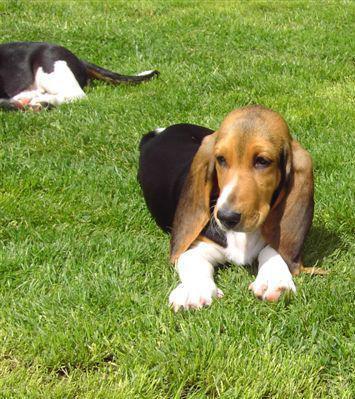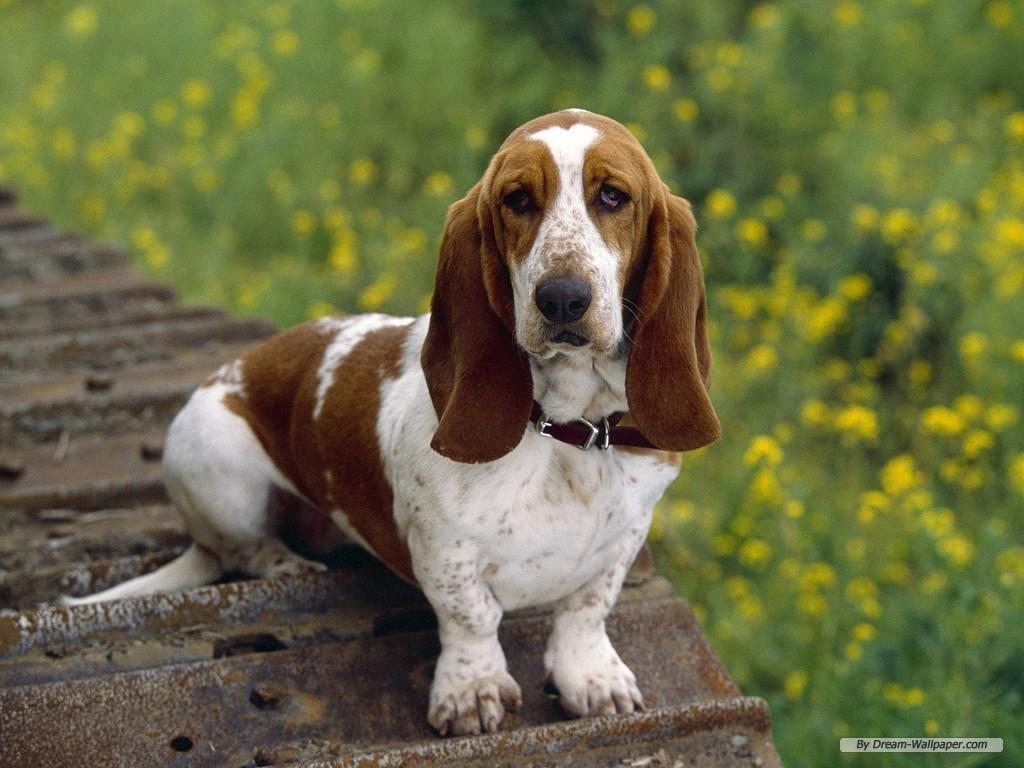The first image is the image on the left, the second image is the image on the right. Examine the images to the left and right. Is the description "A dogs tongue is sticking way out." accurate? Answer yes or no. No. The first image is the image on the left, the second image is the image on the right. For the images shown, is this caption "A basset hound is showing its tongue in exactly one of the photos." true? Answer yes or no. No. 